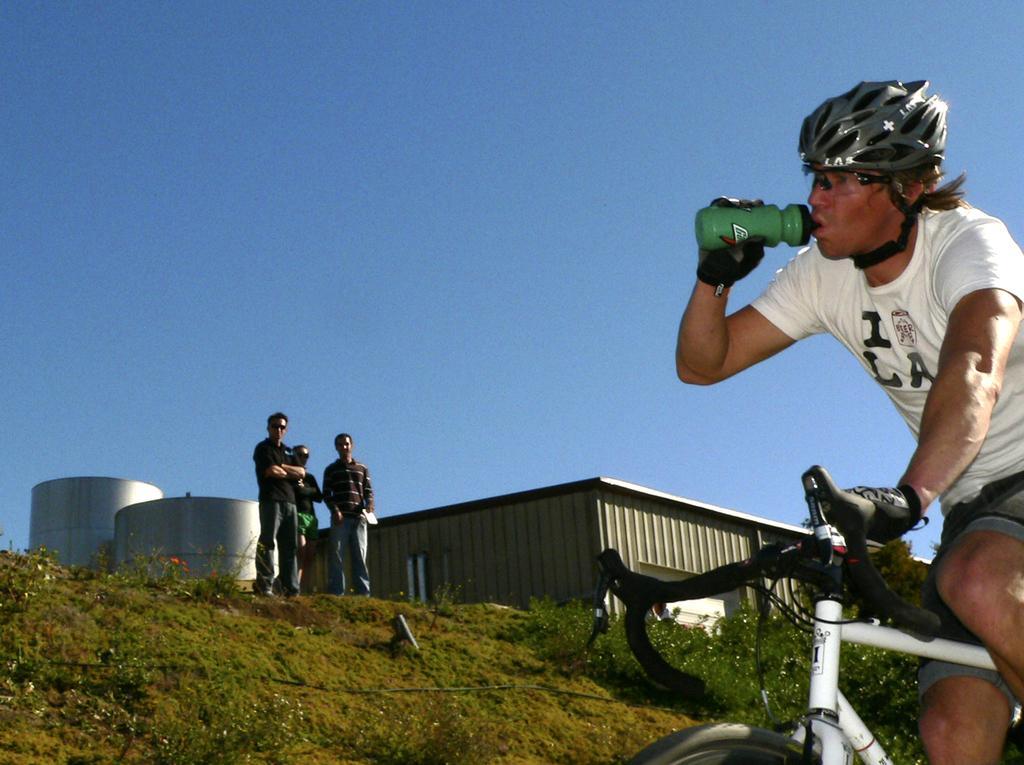Describe this image in one or two sentences. This is an outside view. On the right side there is a man wearing a helmet to the head, holding a bottle in the hand and riding a bicycle towards the left side. On the left side there are three persons standing and looking at this man. There are few plants on the ground. In the background there is a shed and few metal objects. At the top of the image I can see the sky. 